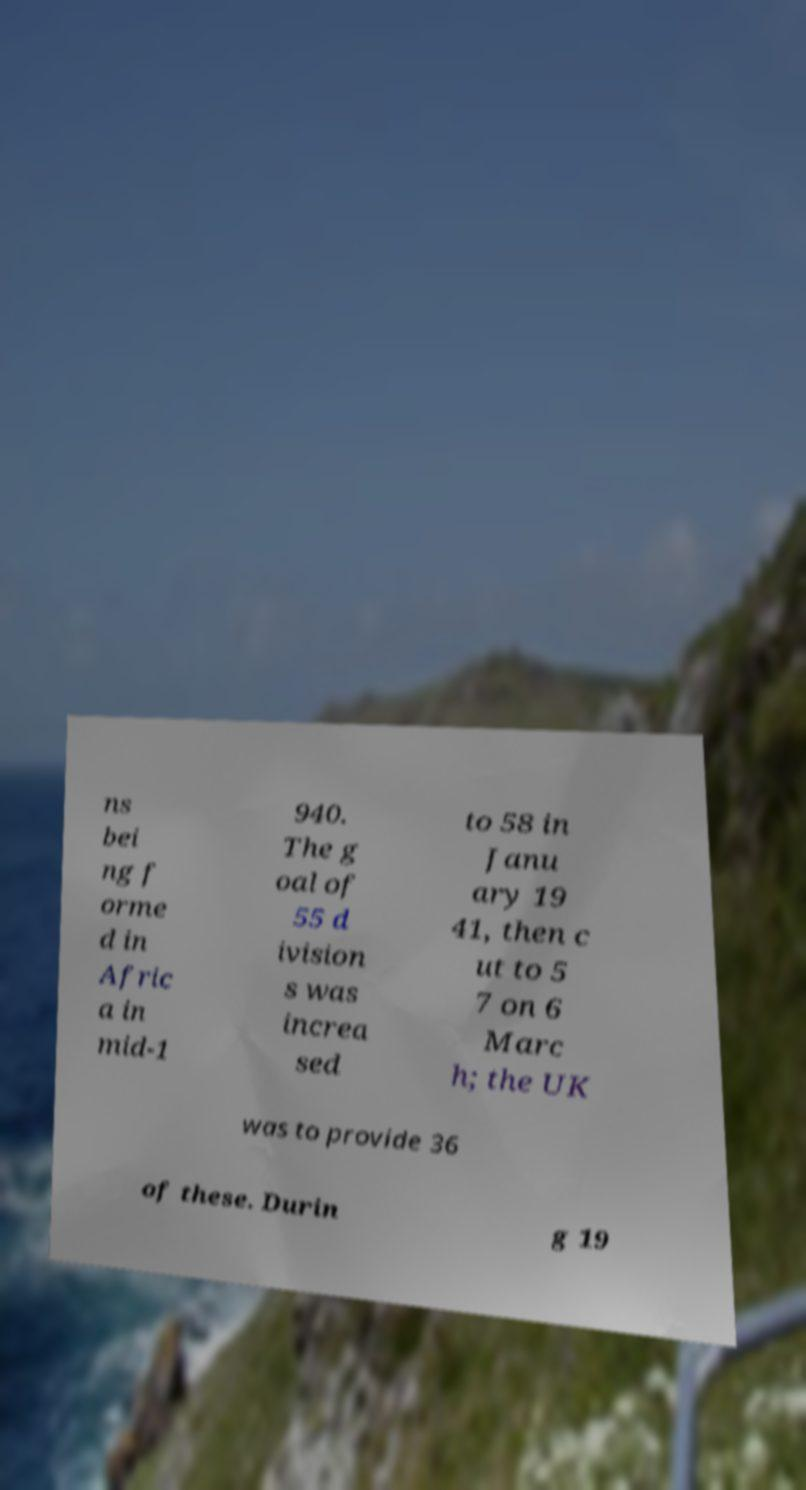What messages or text are displayed in this image? I need them in a readable, typed format. ns bei ng f orme d in Afric a in mid-1 940. The g oal of 55 d ivision s was increa sed to 58 in Janu ary 19 41, then c ut to 5 7 on 6 Marc h; the UK was to provide 36 of these. Durin g 19 